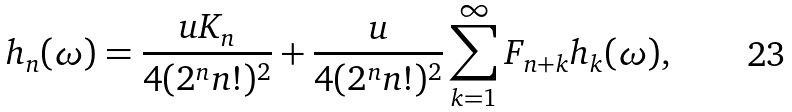<formula> <loc_0><loc_0><loc_500><loc_500>h _ { n } ( \omega ) = \frac { u K _ { n } } { 4 ( 2 ^ { n } n ! ) ^ { 2 } } + \frac { u } { 4 ( 2 ^ { n } n ! ) ^ { 2 } } \sum _ { k = 1 } ^ { \infty } F _ { n + k } h _ { k } ( \omega ) ,</formula> 